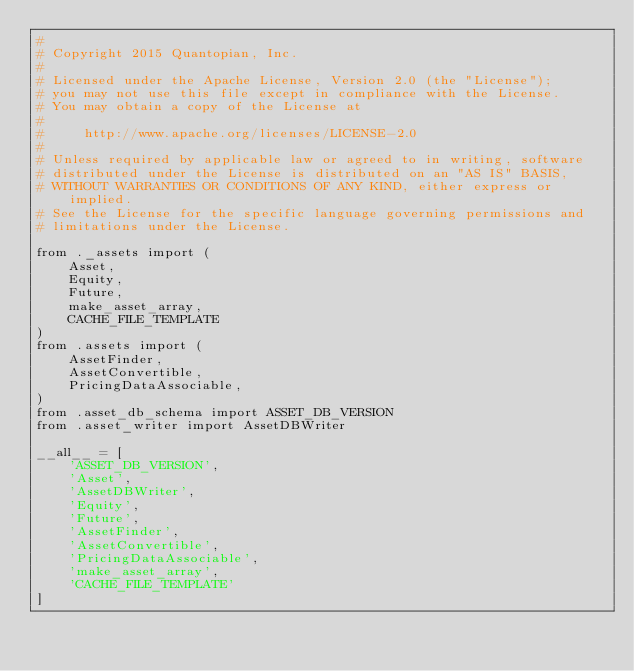<code> <loc_0><loc_0><loc_500><loc_500><_Python_>#
# Copyright 2015 Quantopian, Inc.
#
# Licensed under the Apache License, Version 2.0 (the "License");
# you may not use this file except in compliance with the License.
# You may obtain a copy of the License at
#
#     http://www.apache.org/licenses/LICENSE-2.0
#
# Unless required by applicable law or agreed to in writing, software
# distributed under the License is distributed on an "AS IS" BASIS,
# WITHOUT WARRANTIES OR CONDITIONS OF ANY KIND, either express or implied.
# See the License for the specific language governing permissions and
# limitations under the License.

from ._assets import (
    Asset,
    Equity,
    Future,
    make_asset_array,
    CACHE_FILE_TEMPLATE
)
from .assets import (
    AssetFinder,
    AssetConvertible,
    PricingDataAssociable,
)
from .asset_db_schema import ASSET_DB_VERSION
from .asset_writer import AssetDBWriter

__all__ = [
    'ASSET_DB_VERSION',
    'Asset',
    'AssetDBWriter',
    'Equity',
    'Future',
    'AssetFinder',
    'AssetConvertible',
    'PricingDataAssociable',
    'make_asset_array',
    'CACHE_FILE_TEMPLATE'
]
</code> 